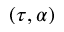<formula> <loc_0><loc_0><loc_500><loc_500>( \tau , \alpha )</formula> 